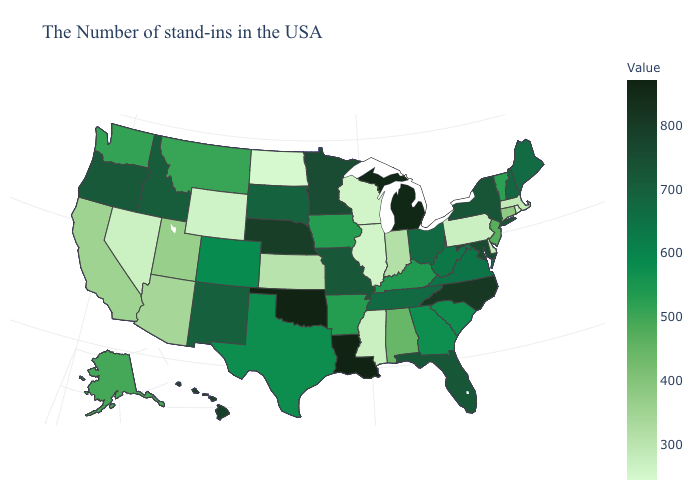Does Alabama have a lower value than Louisiana?
Short answer required. Yes. Does Louisiana have the highest value in the South?
Quick response, please. Yes. Does Louisiana have the highest value in the USA?
Keep it brief. Yes. 